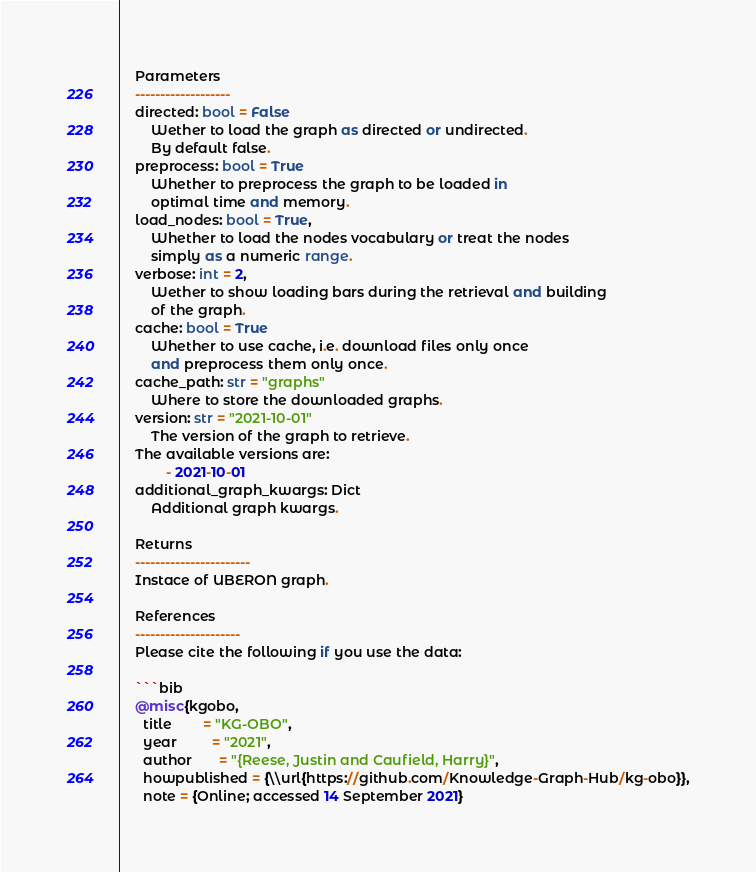Convert code to text. <code><loc_0><loc_0><loc_500><loc_500><_Python_>    Parameters
    -------------------
    directed: bool = False
        Wether to load the graph as directed or undirected.
        By default false.
    preprocess: bool = True
        Whether to preprocess the graph to be loaded in 
        optimal time and memory.
    load_nodes: bool = True,
        Whether to load the nodes vocabulary or treat the nodes
        simply as a numeric range.
    verbose: int = 2,
        Wether to show loading bars during the retrieval and building
        of the graph.
    cache: bool = True
        Whether to use cache, i.e. download files only once
        and preprocess them only once.
    cache_path: str = "graphs"
        Where to store the downloaded graphs.
    version: str = "2021-10-01"
        The version of the graph to retrieve.		
	The available versions are:
			- 2021-10-01
    additional_graph_kwargs: Dict
        Additional graph kwargs.

    Returns
    -----------------------
    Instace of UBERON graph.

	References
	---------------------
	Please cite the following if you use the data:
	
	```bib
	@misc{kgobo,
	  title        = "KG-OBO",
	  year         = "2021",
	  author       = "{Reese, Justin and Caufield, Harry}",
	  howpublished = {\\url{https://github.com/Knowledge-Graph-Hub/kg-obo}},
	  note = {Online; accessed 14 September 2021}</code> 